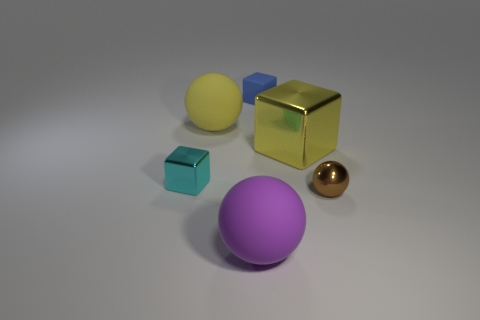Are there more matte spheres that are behind the small cyan object than large red blocks?
Keep it short and to the point. Yes. Do the tiny object that is behind the yellow metal thing and the big yellow matte object have the same shape?
Offer a very short reply. No. Is there a big shiny thing that has the same shape as the small cyan metal thing?
Offer a very short reply. Yes. What number of things are shiny blocks that are to the right of the blue rubber cube or small metal balls?
Your answer should be very brief. 2. Is the number of large red matte balls greater than the number of blue matte blocks?
Offer a very short reply. No. Is there a brown object that has the same size as the rubber block?
Ensure brevity in your answer.  Yes. What number of things are yellow objects that are on the right side of the blue cube or large spheres that are behind the cyan metal object?
Your answer should be compact. 2. What color is the rubber object in front of the shiny thing left of the small rubber thing?
Provide a short and direct response. Purple. There is a big block that is the same material as the small cyan object; what color is it?
Offer a terse response. Yellow. How many big balls are the same color as the big cube?
Ensure brevity in your answer.  1. 